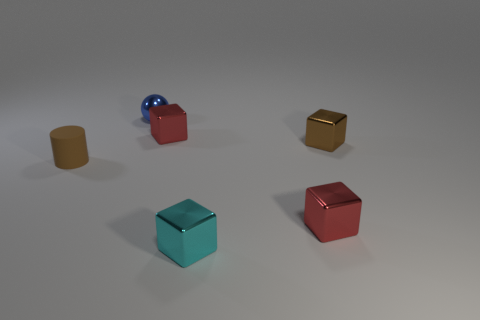Are there any other things that have the same material as the brown cylinder?
Keep it short and to the point. No. What is the size of the cube that is the same color as the tiny rubber cylinder?
Make the answer very short. Small. What is the shape of the metallic object that is behind the tiny cyan metallic object and in front of the cylinder?
Make the answer very short. Cube. Is there a tiny object of the same color as the tiny cylinder?
Offer a very short reply. Yes. Is there a tiny rubber cube?
Keep it short and to the point. No. What is the color of the small thing to the left of the tiny blue metal thing?
Ensure brevity in your answer.  Brown. What size is the cube that is in front of the brown cylinder and behind the small cyan metal thing?
Ensure brevity in your answer.  Small. Is there a brown object made of the same material as the small blue thing?
Make the answer very short. Yes. There is a cyan object; what shape is it?
Offer a very short reply. Cube. How many other things are the same shape as the small blue object?
Offer a very short reply. 0. 